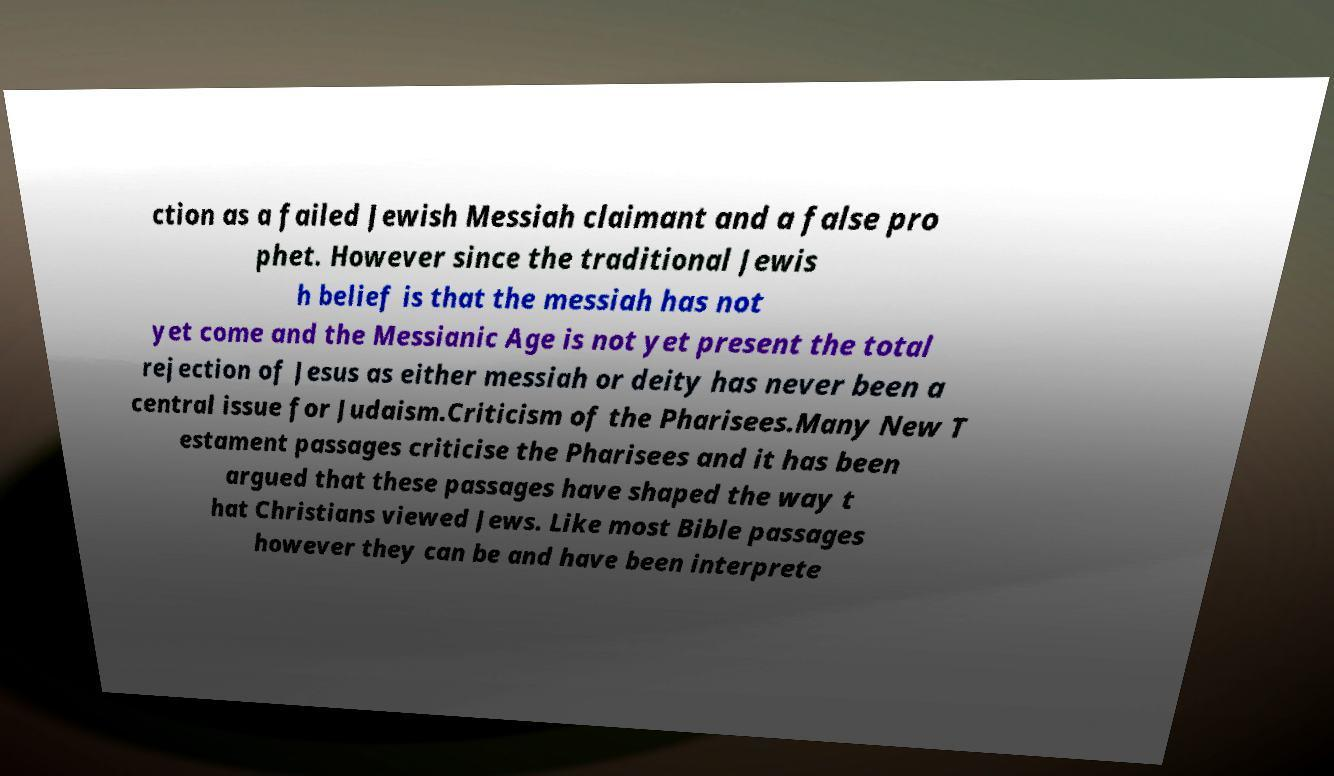Could you assist in decoding the text presented in this image and type it out clearly? ction as a failed Jewish Messiah claimant and a false pro phet. However since the traditional Jewis h belief is that the messiah has not yet come and the Messianic Age is not yet present the total rejection of Jesus as either messiah or deity has never been a central issue for Judaism.Criticism of the Pharisees.Many New T estament passages criticise the Pharisees and it has been argued that these passages have shaped the way t hat Christians viewed Jews. Like most Bible passages however they can be and have been interprete 